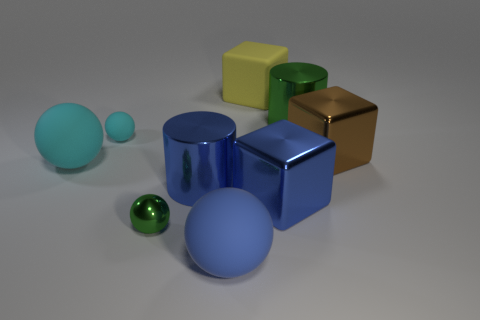Is there any other thing that is the same size as the blue shiny cylinder?
Provide a short and direct response. Yes. What number of big blue metal blocks are to the left of the large rubber ball that is in front of the small metallic ball?
Offer a very short reply. 0. How many green spheres are to the left of the tiny cyan thing?
Provide a short and direct response. 0. There is a cube behind the tiny object that is behind the big cube that is on the right side of the large blue cube; what color is it?
Offer a terse response. Yellow. Does the large cylinder that is on the right side of the yellow rubber cube have the same color as the tiny object that is in front of the brown object?
Your response must be concise. Yes. The tiny object behind the big block right of the big green cylinder is what shape?
Keep it short and to the point. Sphere. Is there a gray shiny thing that has the same size as the green cylinder?
Your answer should be very brief. No. What number of rubber things are the same shape as the tiny shiny thing?
Your answer should be compact. 3. Are there the same number of spheres that are in front of the small green shiny ball and large metallic blocks on the left side of the large brown block?
Give a very brief answer. Yes. Are there any tiny yellow metallic cylinders?
Offer a terse response. No. 